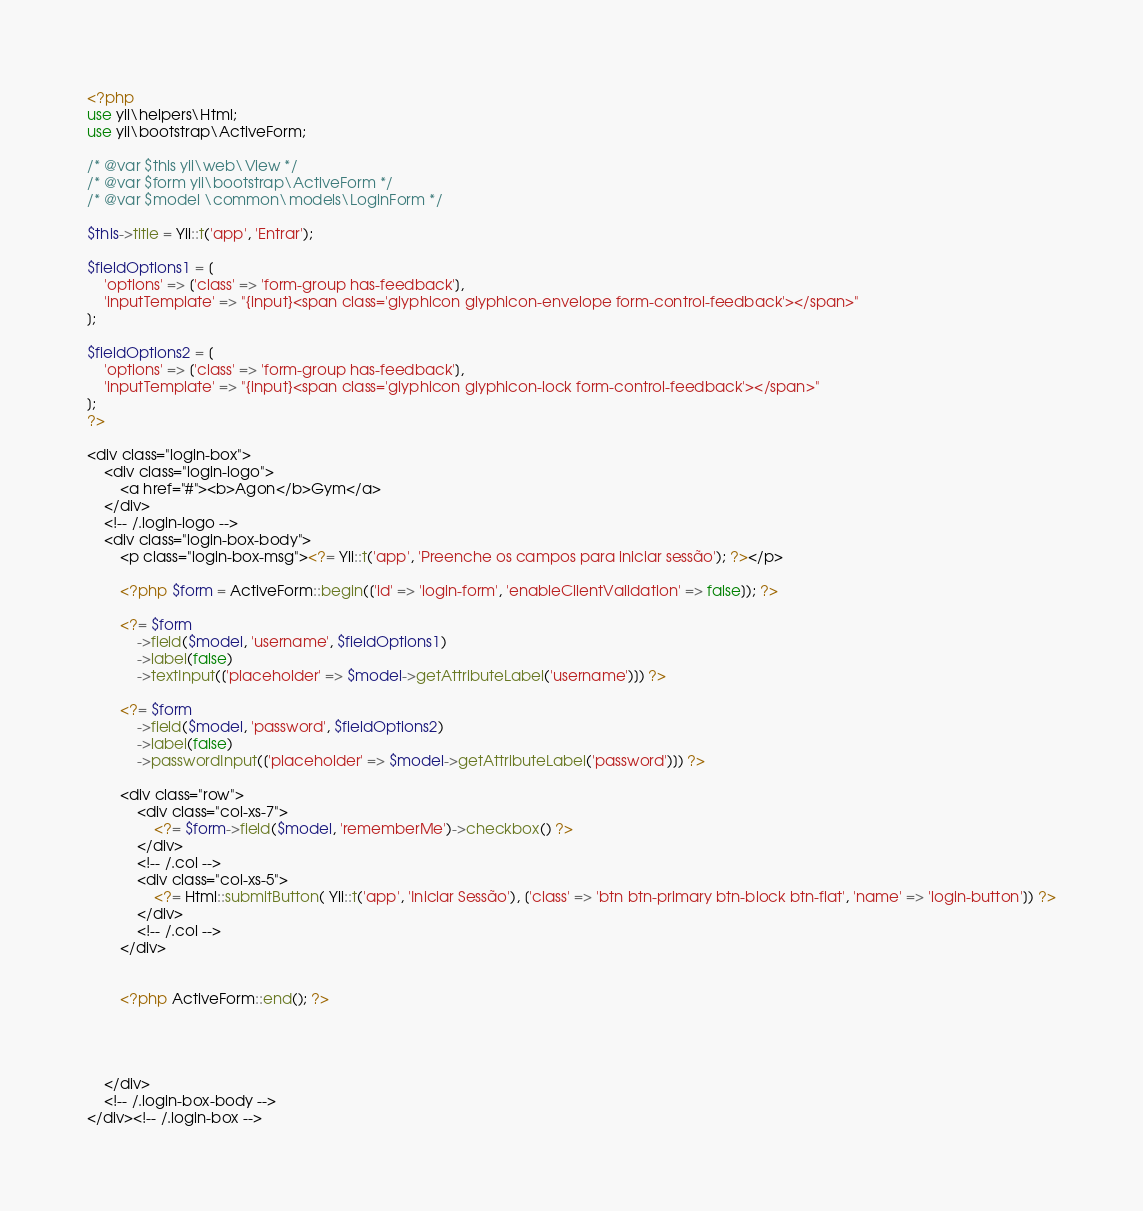<code> <loc_0><loc_0><loc_500><loc_500><_PHP_><?php
use yii\helpers\Html;
use yii\bootstrap\ActiveForm;

/* @var $this yii\web\View */
/* @var $form yii\bootstrap\ActiveForm */
/* @var $model \common\models\LoginForm */

$this->title = Yii::t('app', 'Entrar');

$fieldOptions1 = [
    'options' => ['class' => 'form-group has-feedback'],
    'inputTemplate' => "{input}<span class='glyphicon glyphicon-envelope form-control-feedback'></span>"
];

$fieldOptions2 = [
    'options' => ['class' => 'form-group has-feedback'],
    'inputTemplate' => "{input}<span class='glyphicon glyphicon-lock form-control-feedback'></span>"
];
?>

<div class="login-box">
    <div class="login-logo">
        <a href="#"><b>Agon</b>Gym</a>
    </div>
    <!-- /.login-logo -->
    <div class="login-box-body">
        <p class="login-box-msg"><?= Yii::t('app', 'Preenche os campos para iniciar sessão'); ?></p>

        <?php $form = ActiveForm::begin(['id' => 'login-form', 'enableClientValidation' => false]); ?>

        <?= $form
            ->field($model, 'username', $fieldOptions1)
            ->label(false)
            ->textInput(['placeholder' => $model->getAttributeLabel('username')]) ?>

        <?= $form
            ->field($model, 'password', $fieldOptions2)
            ->label(false)
            ->passwordInput(['placeholder' => $model->getAttributeLabel('password')]) ?>

        <div class="row">
            <div class="col-xs-7">
                <?= $form->field($model, 'rememberMe')->checkbox() ?>
            </div>
            <!-- /.col -->
            <div class="col-xs-5">
                <?= Html::submitButton( Yii::t('app', 'Iniciar Sessão'), ['class' => 'btn btn-primary btn-block btn-flat', 'name' => 'login-button']) ?>
            </div>
            <!-- /.col -->
        </div>


        <?php ActiveForm::end(); ?>

      
       

    </div>
    <!-- /.login-box-body -->
</div><!-- /.login-box -->
</code> 